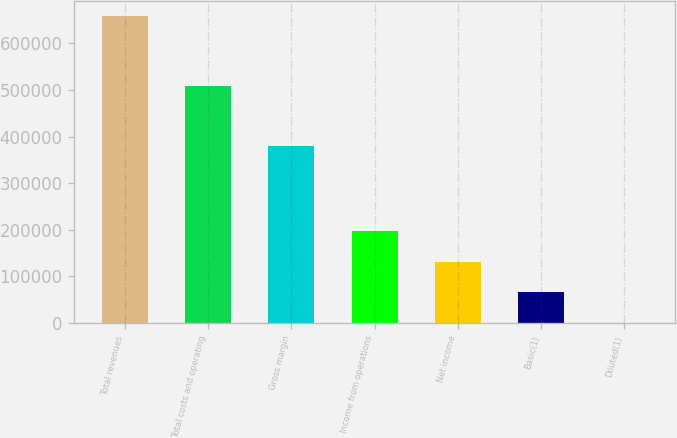Convert chart. <chart><loc_0><loc_0><loc_500><loc_500><bar_chart><fcel>Total revenues<fcel>Total costs and operating<fcel>Gross margin<fcel>Income from operations<fcel>Net income<fcel>Basic(1)<fcel>Diluted(1)<nl><fcel>658337<fcel>508426<fcel>380680<fcel>197502<fcel>131668<fcel>65834.3<fcel>0.66<nl></chart> 